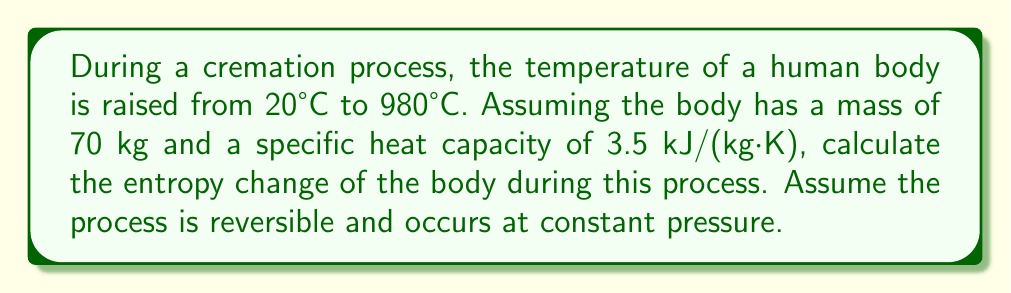Show me your answer to this math problem. To calculate the entropy change during the cremation process, we'll use the formula for entropy change in a reversible process at constant pressure:

$$\Delta S = mc_p \ln\left(\frac{T_f}{T_i}\right)$$

Where:
$\Delta S$ = entropy change (kJ/K)
$m$ = mass of the body (kg)
$c_p$ = specific heat capacity (kJ/(kg·K))
$T_f$ = final temperature (K)
$T_i$ = initial temperature (K)

Step 1: Convert temperatures to Kelvin
$T_i = 20°C + 273.15 = 293.15$ K
$T_f = 980°C + 273.15 = 1253.15$ K

Step 2: Substitute the values into the equation
$$\Delta S = 70 \text{ kg} \cdot 3.5 \frac{\text{kJ}}{\text{kg·K}} \cdot \ln\left(\frac{1253.15 \text{ K}}{293.15 \text{ K}}\right)$$

Step 3: Calculate the natural logarithm
$$\Delta S = 245 \frac{\text{kJ}}{\text{K}} \cdot \ln(4.2747)$$

Step 4: Compute the final result
$$\Delta S = 245 \frac{\text{kJ}}{\text{K}} \cdot 1.4526 = 355.89 \frac{\text{kJ}}{\text{K}}$$
Answer: $355.89 \text{ kJ/K}$ 